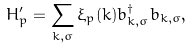<formula> <loc_0><loc_0><loc_500><loc_500>H _ { p } ^ { \prime } = \sum _ { k , \sigma } \xi _ { p } ( k ) b _ { k , \sigma } ^ { \dagger } b _ { k , \sigma } ,</formula> 